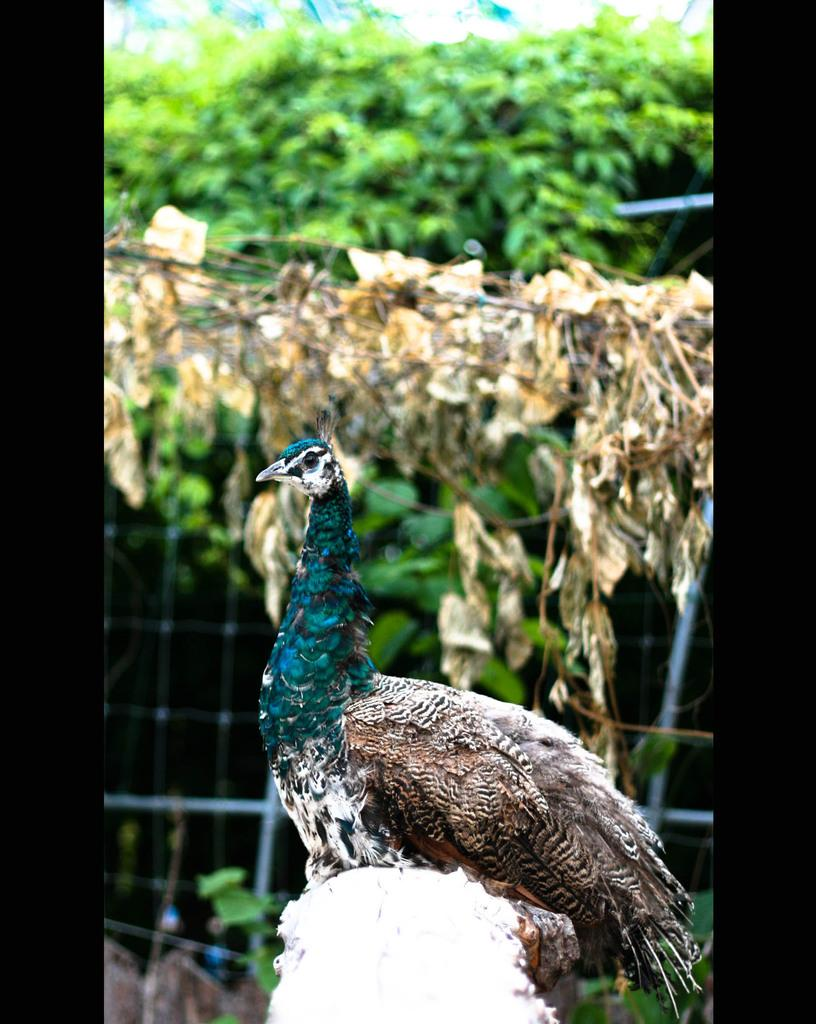What type of animal is in the image? There is a peacock in the image. What can be seen in the background of the image? There are trees in the image. What type of structure is present in the image? There is fencing in the image. What type of cream can be seen on the wall in the image? There is no cream or wall present in the image; it features a peacock, trees, and fencing. 